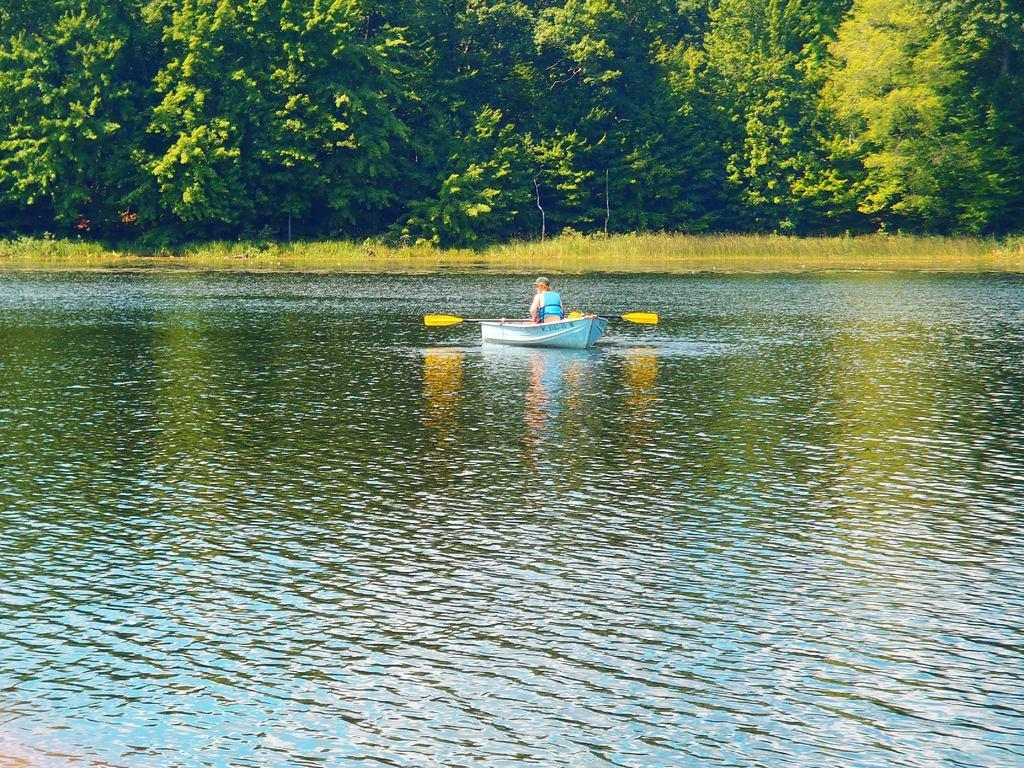What is the main subject of the person doing in the image? There is a person on a boat in the image. Where is the boat located? The boat is in the water. What can be seen in the background of the image? There are trees in the background of the image. What is visible at the bottom of the image? The water is visible at the bottom of the image. What type of protest is happening in the image? There is no protest present in the image; it features a person on a boat in the water. What type of plough is being used in the image? There is no plough present in the image; it features a person on a boat in the water. 